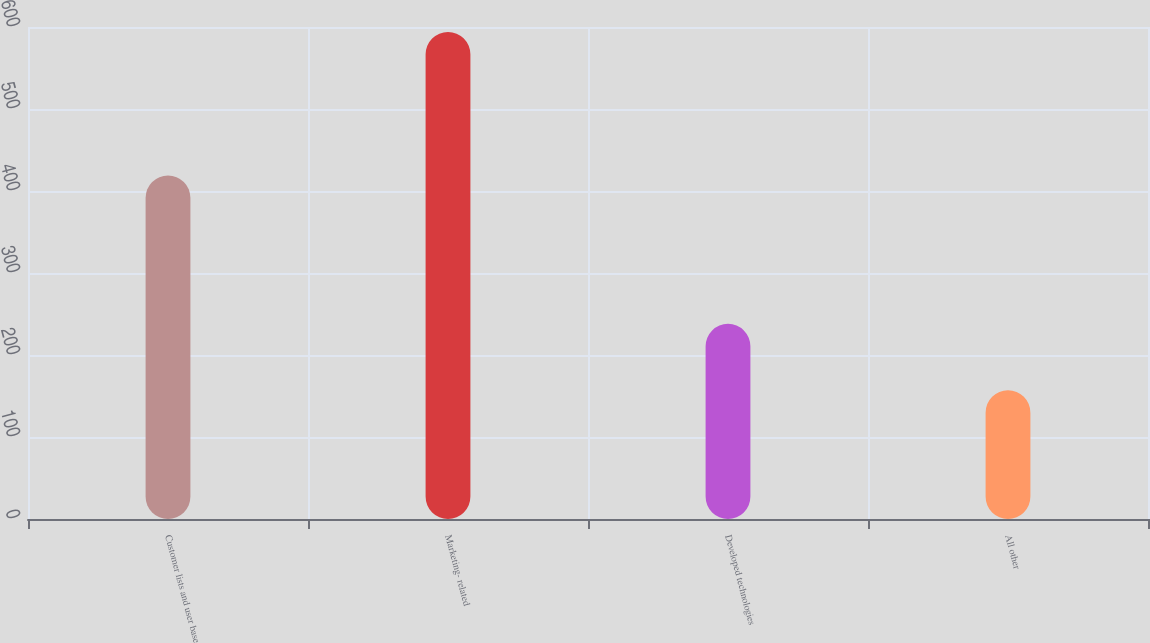Convert chart to OTSL. <chart><loc_0><loc_0><loc_500><loc_500><bar_chart><fcel>Customer lists and user base<fcel>Marketing- related<fcel>Developed technologies<fcel>All other<nl><fcel>419<fcel>594<fcel>238<fcel>157<nl></chart> 